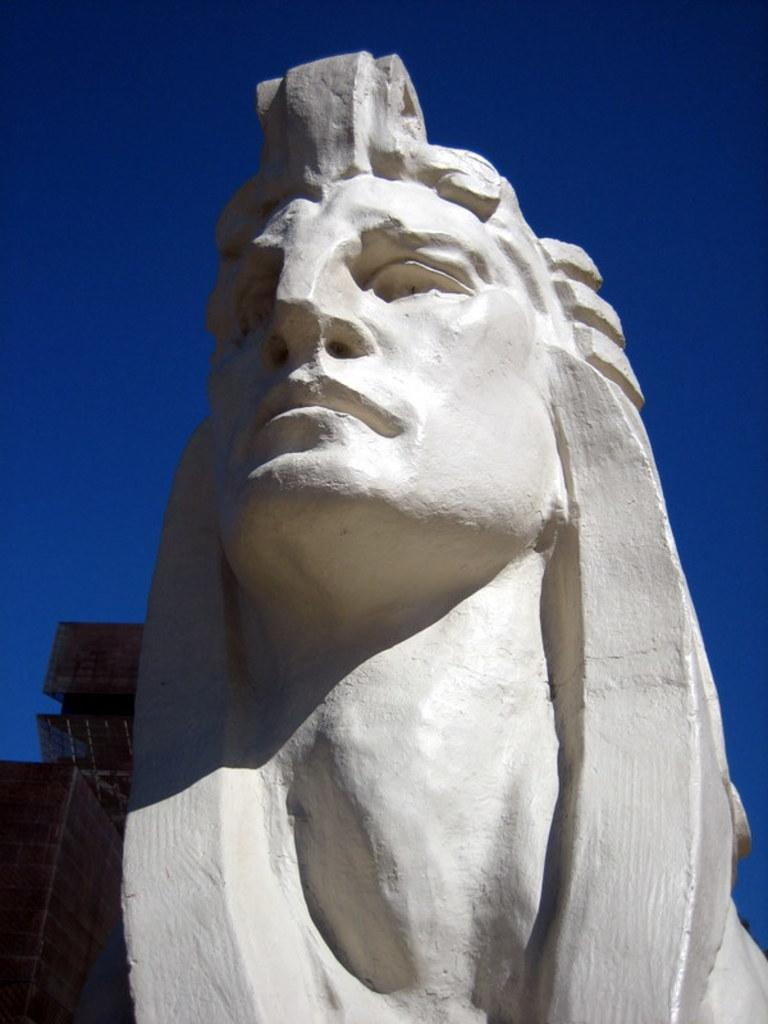What is the main subject of the image? There is a sculpture of a woman in the image. Where is the sculpture located in the image? The sculpture is located towards the bottom of the image. What can be seen on the left side of the image? There is a wall towards the left side of the image. What is visible in the background of the image? The sky is visible in the background of the image. What type of pen is the creator using to draw the sculpture in the image? There is no pen or drawing process depicted in the image; it features a completed sculpture of a woman. 